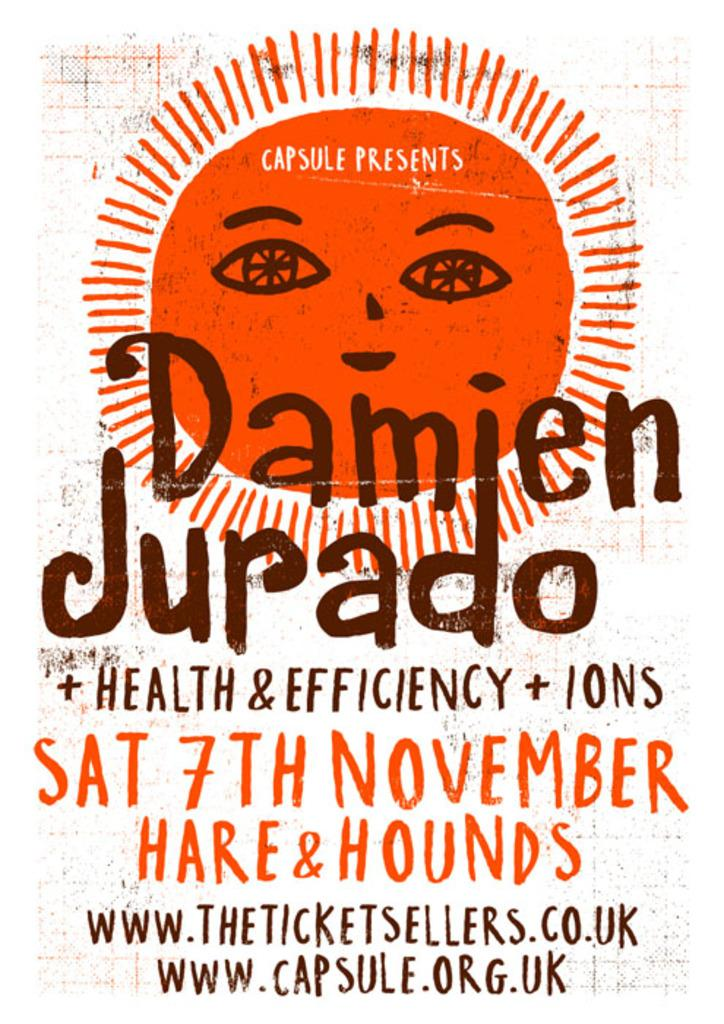Provide a one-sentence caption for the provided image. Concert poster for Damien Jurado and Health and Efficiency and others. 